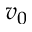Convert formula to latex. <formula><loc_0><loc_0><loc_500><loc_500>v _ { 0 }</formula> 